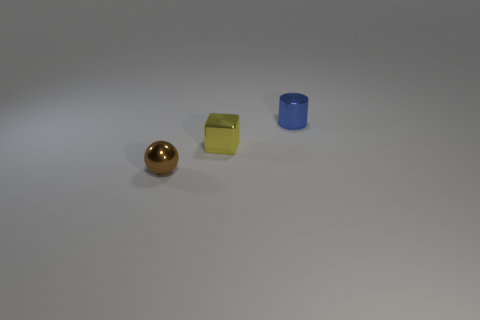What number of other objects are the same material as the small block?
Keep it short and to the point. 2. There is a blue cylinder that is the same size as the yellow metallic block; what material is it?
Your answer should be compact. Metal. What number of green things are cylinders or tiny things?
Offer a very short reply. 0. What is the color of the small metal object that is both on the right side of the ball and on the left side of the blue metallic thing?
Your answer should be compact. Yellow. Do the thing that is to the right of the small yellow block and the tiny thing that is on the left side of the small yellow metallic cube have the same material?
Your answer should be compact. Yes. Are there more blue metal cylinders that are on the left side of the yellow block than small yellow blocks that are left of the tiny brown shiny object?
Give a very brief answer. No. There is a yellow thing that is the same size as the brown sphere; what is its shape?
Provide a succinct answer. Cube. What number of objects are small red metal objects or tiny metallic objects in front of the blue object?
Offer a terse response. 2. Does the sphere have the same color as the small cylinder?
Your answer should be compact. No. How many shiny objects are left of the yellow cube?
Offer a very short reply. 1. 